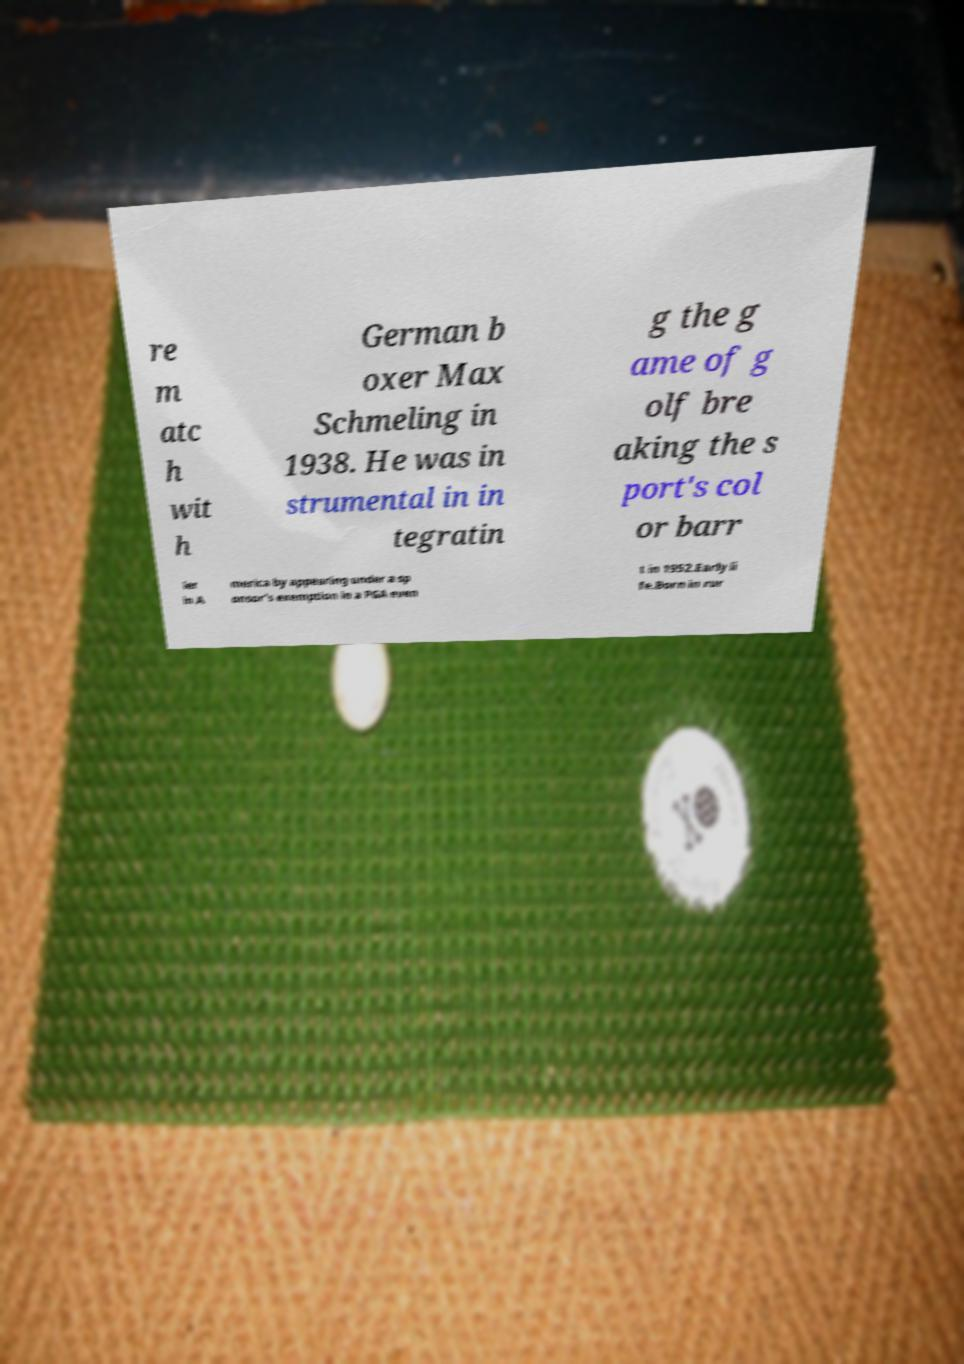What messages or text are displayed in this image? I need them in a readable, typed format. re m atc h wit h German b oxer Max Schmeling in 1938. He was in strumental in in tegratin g the g ame of g olf bre aking the s port's col or barr ier in A merica by appearing under a sp onsor's exemption in a PGA even t in 1952.Early li fe.Born in rur 